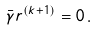<formula> <loc_0><loc_0><loc_500><loc_500>\bar { \gamma } r ^ { ( k + 1 ) } = 0 \, .</formula> 